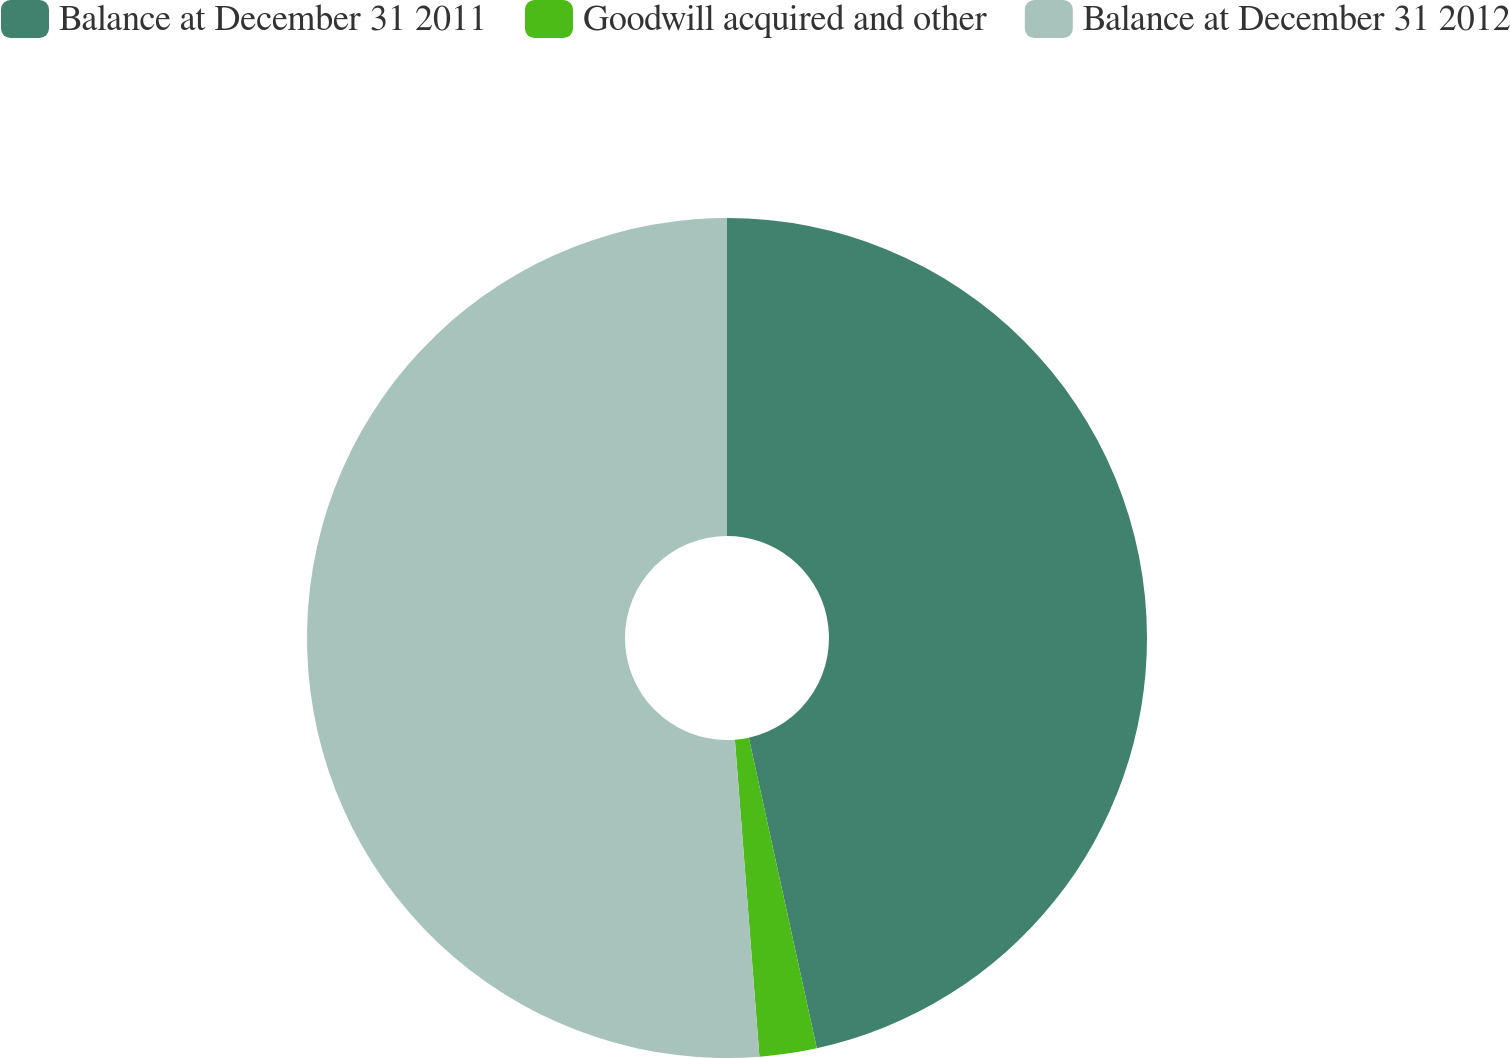Convert chart to OTSL. <chart><loc_0><loc_0><loc_500><loc_500><pie_chart><fcel>Balance at December 31 2011<fcel>Goodwill acquired and other<fcel>Balance at December 31 2012<nl><fcel>46.57%<fcel>2.2%<fcel>51.23%<nl></chart> 